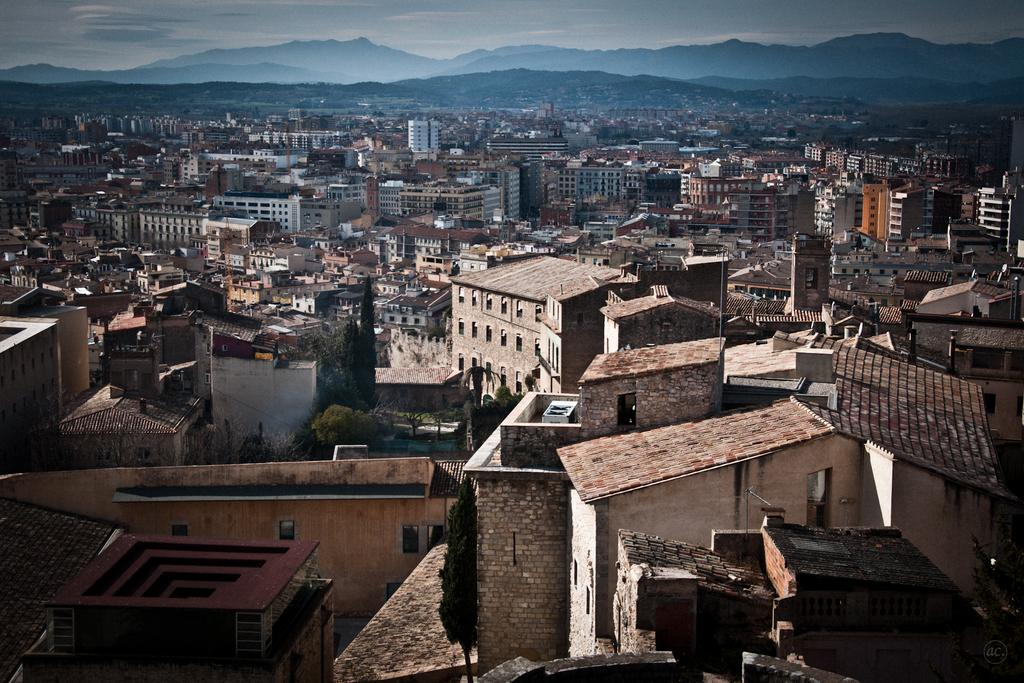What type of structures can be seen in the image? There are buildings in the image. What type of natural vegetation is present in the image? There are trees in the image. What type of geographical feature can be seen in the image? There are hills in the image. What is the condition of the sky in the image? The sky is cloudy in the image. Can you tell me how many dogs are present in the image? There are no dogs present in the image. What type of invention is being used by the trees in the image? There is no invention present in the image, and the trees are natural vegetation. 